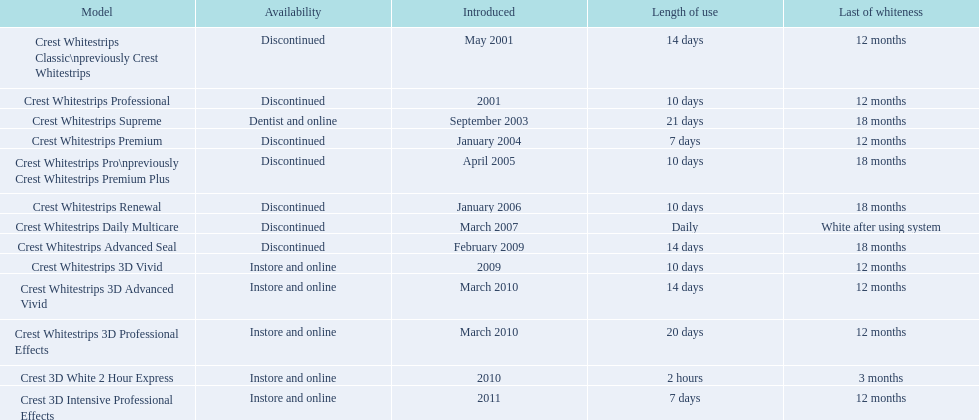When did crest whitestrips 3d advanced vivid make its debut? March 2010. What other item was introduced in march 2010? Crest Whitestrips 3D Professional Effects. 